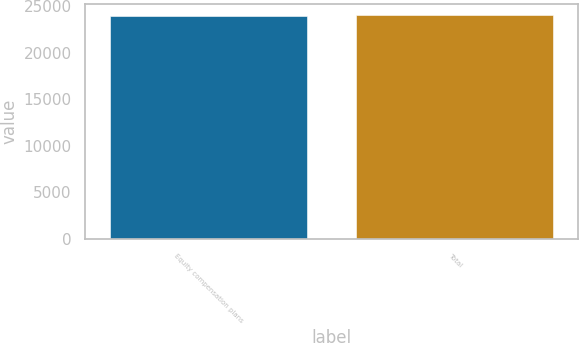<chart> <loc_0><loc_0><loc_500><loc_500><bar_chart><fcel>Equity compensation plans<fcel>Total<nl><fcel>23926<fcel>23996<nl></chart> 